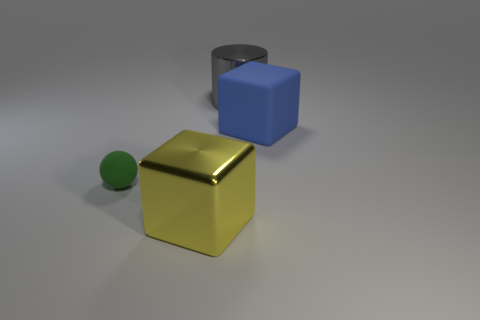Add 1 yellow objects. How many objects exist? 5 Subtract all balls. How many objects are left? 3 Subtract 1 blocks. How many blocks are left? 1 Subtract all yellow blocks. How many blocks are left? 1 Add 3 gray cylinders. How many gray cylinders are left? 4 Add 2 purple things. How many purple things exist? 2 Subtract 1 gray cylinders. How many objects are left? 3 Subtract all gray balls. Subtract all purple blocks. How many balls are left? 1 Subtract all brown cylinders. How many cyan spheres are left? 0 Subtract all green rubber things. Subtract all rubber balls. How many objects are left? 2 